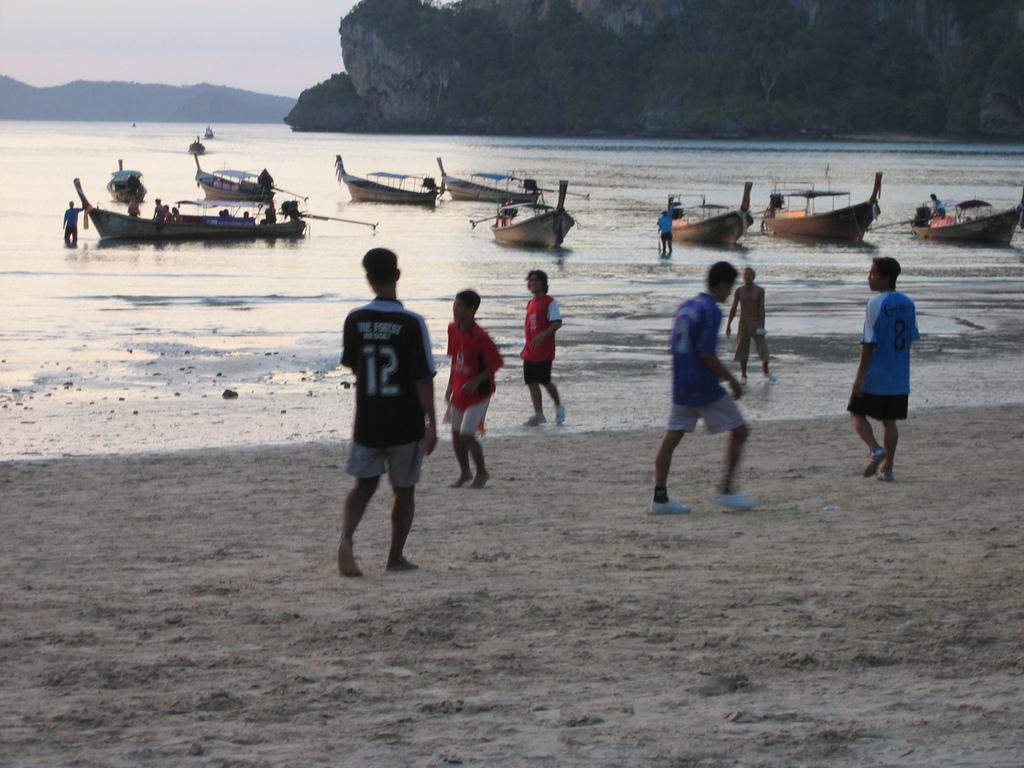Can you describe this image briefly? In this image we can see group of persons standing on the ground. In the center of the image we can see group of boats, some persons standing in water. In the background, we can see mountains and the sky. 